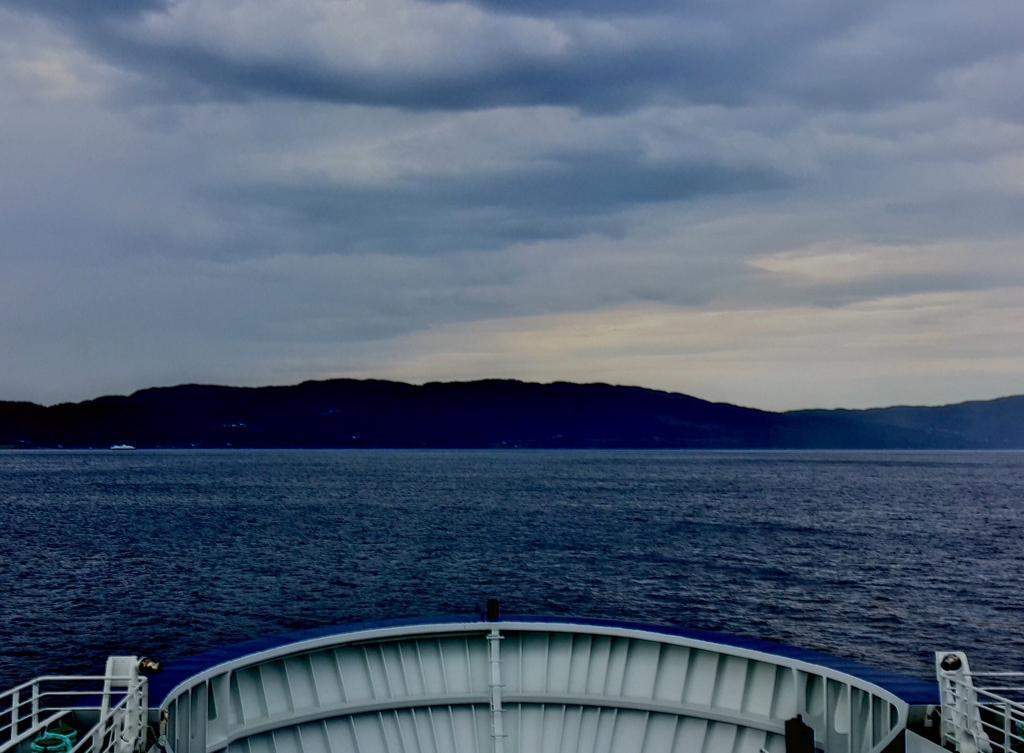Could you give a brief overview of what you see in this image? At the bottom of the image we can find few metal rods, in the background we can see water, few hills and clouds. 